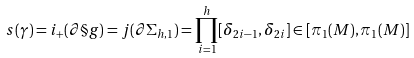<formula> <loc_0><loc_0><loc_500><loc_500>s ( \gamma ) = i _ { + } ( \partial \S g ) = j ( \partial \Sigma _ { h , 1 } ) = \prod _ { i = 1 } ^ { h } [ \delta _ { 2 i - 1 } , \delta _ { 2 i } ] \in [ \pi _ { 1 } ( M ) , \pi _ { 1 } ( M ) ]</formula> 